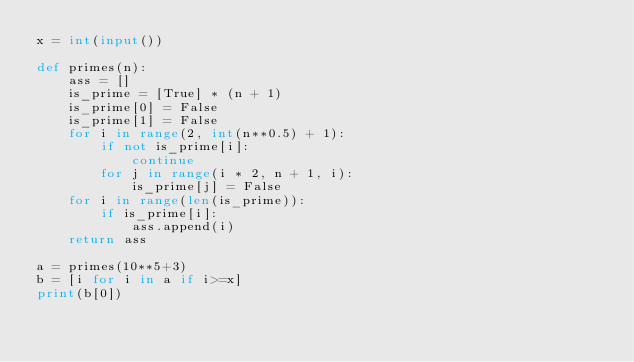Convert code to text. <code><loc_0><loc_0><loc_500><loc_500><_Python_>x = int(input())

def primes(n):
    ass = []
    is_prime = [True] * (n + 1)
    is_prime[0] = False
    is_prime[1] = False
    for i in range(2, int(n**0.5) + 1):
        if not is_prime[i]:
            continue
        for j in range(i * 2, n + 1, i):
            is_prime[j] = False
    for i in range(len(is_prime)):
        if is_prime[i]:
            ass.append(i)
    return ass

a = primes(10**5+3)
b = [i for i in a if i>=x]
print(b[0])</code> 